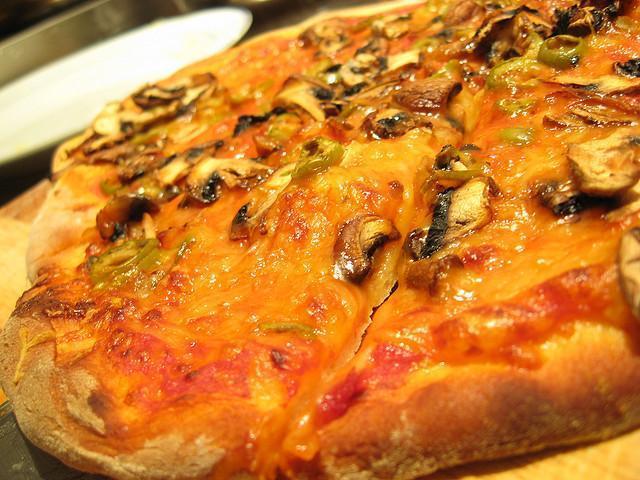How many pizzas are there?
Give a very brief answer. 1. 